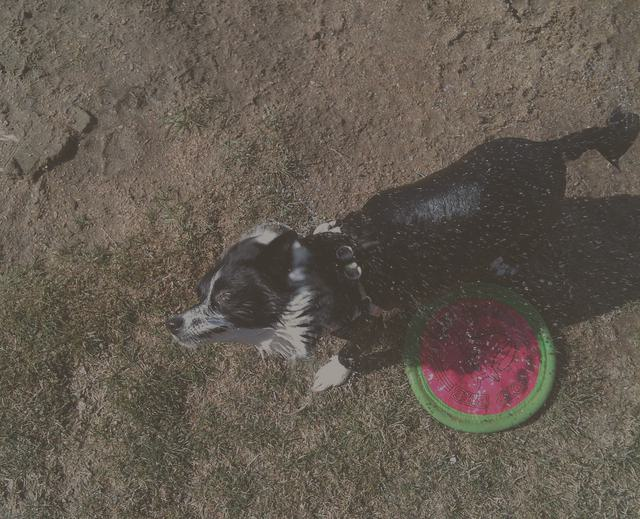Are all the texture details of the small dog intact? The image shows a small dog with mostly visible texture details. However, due to shadows and highlights caused by bright sunlight, as well as the dog's movement which may cause minor blurring, it's possible that not all minute texture details are perfectly intact. The image resolution and quality also play a role in how clearly the texture details can be perceived. 